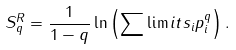Convert formula to latex. <formula><loc_0><loc_0><loc_500><loc_500>S _ { q } ^ { R } = \frac { 1 } { 1 - q } \ln \left ( \sum \lim i t s _ { i } p _ { i } ^ { q } \right ) .</formula> 